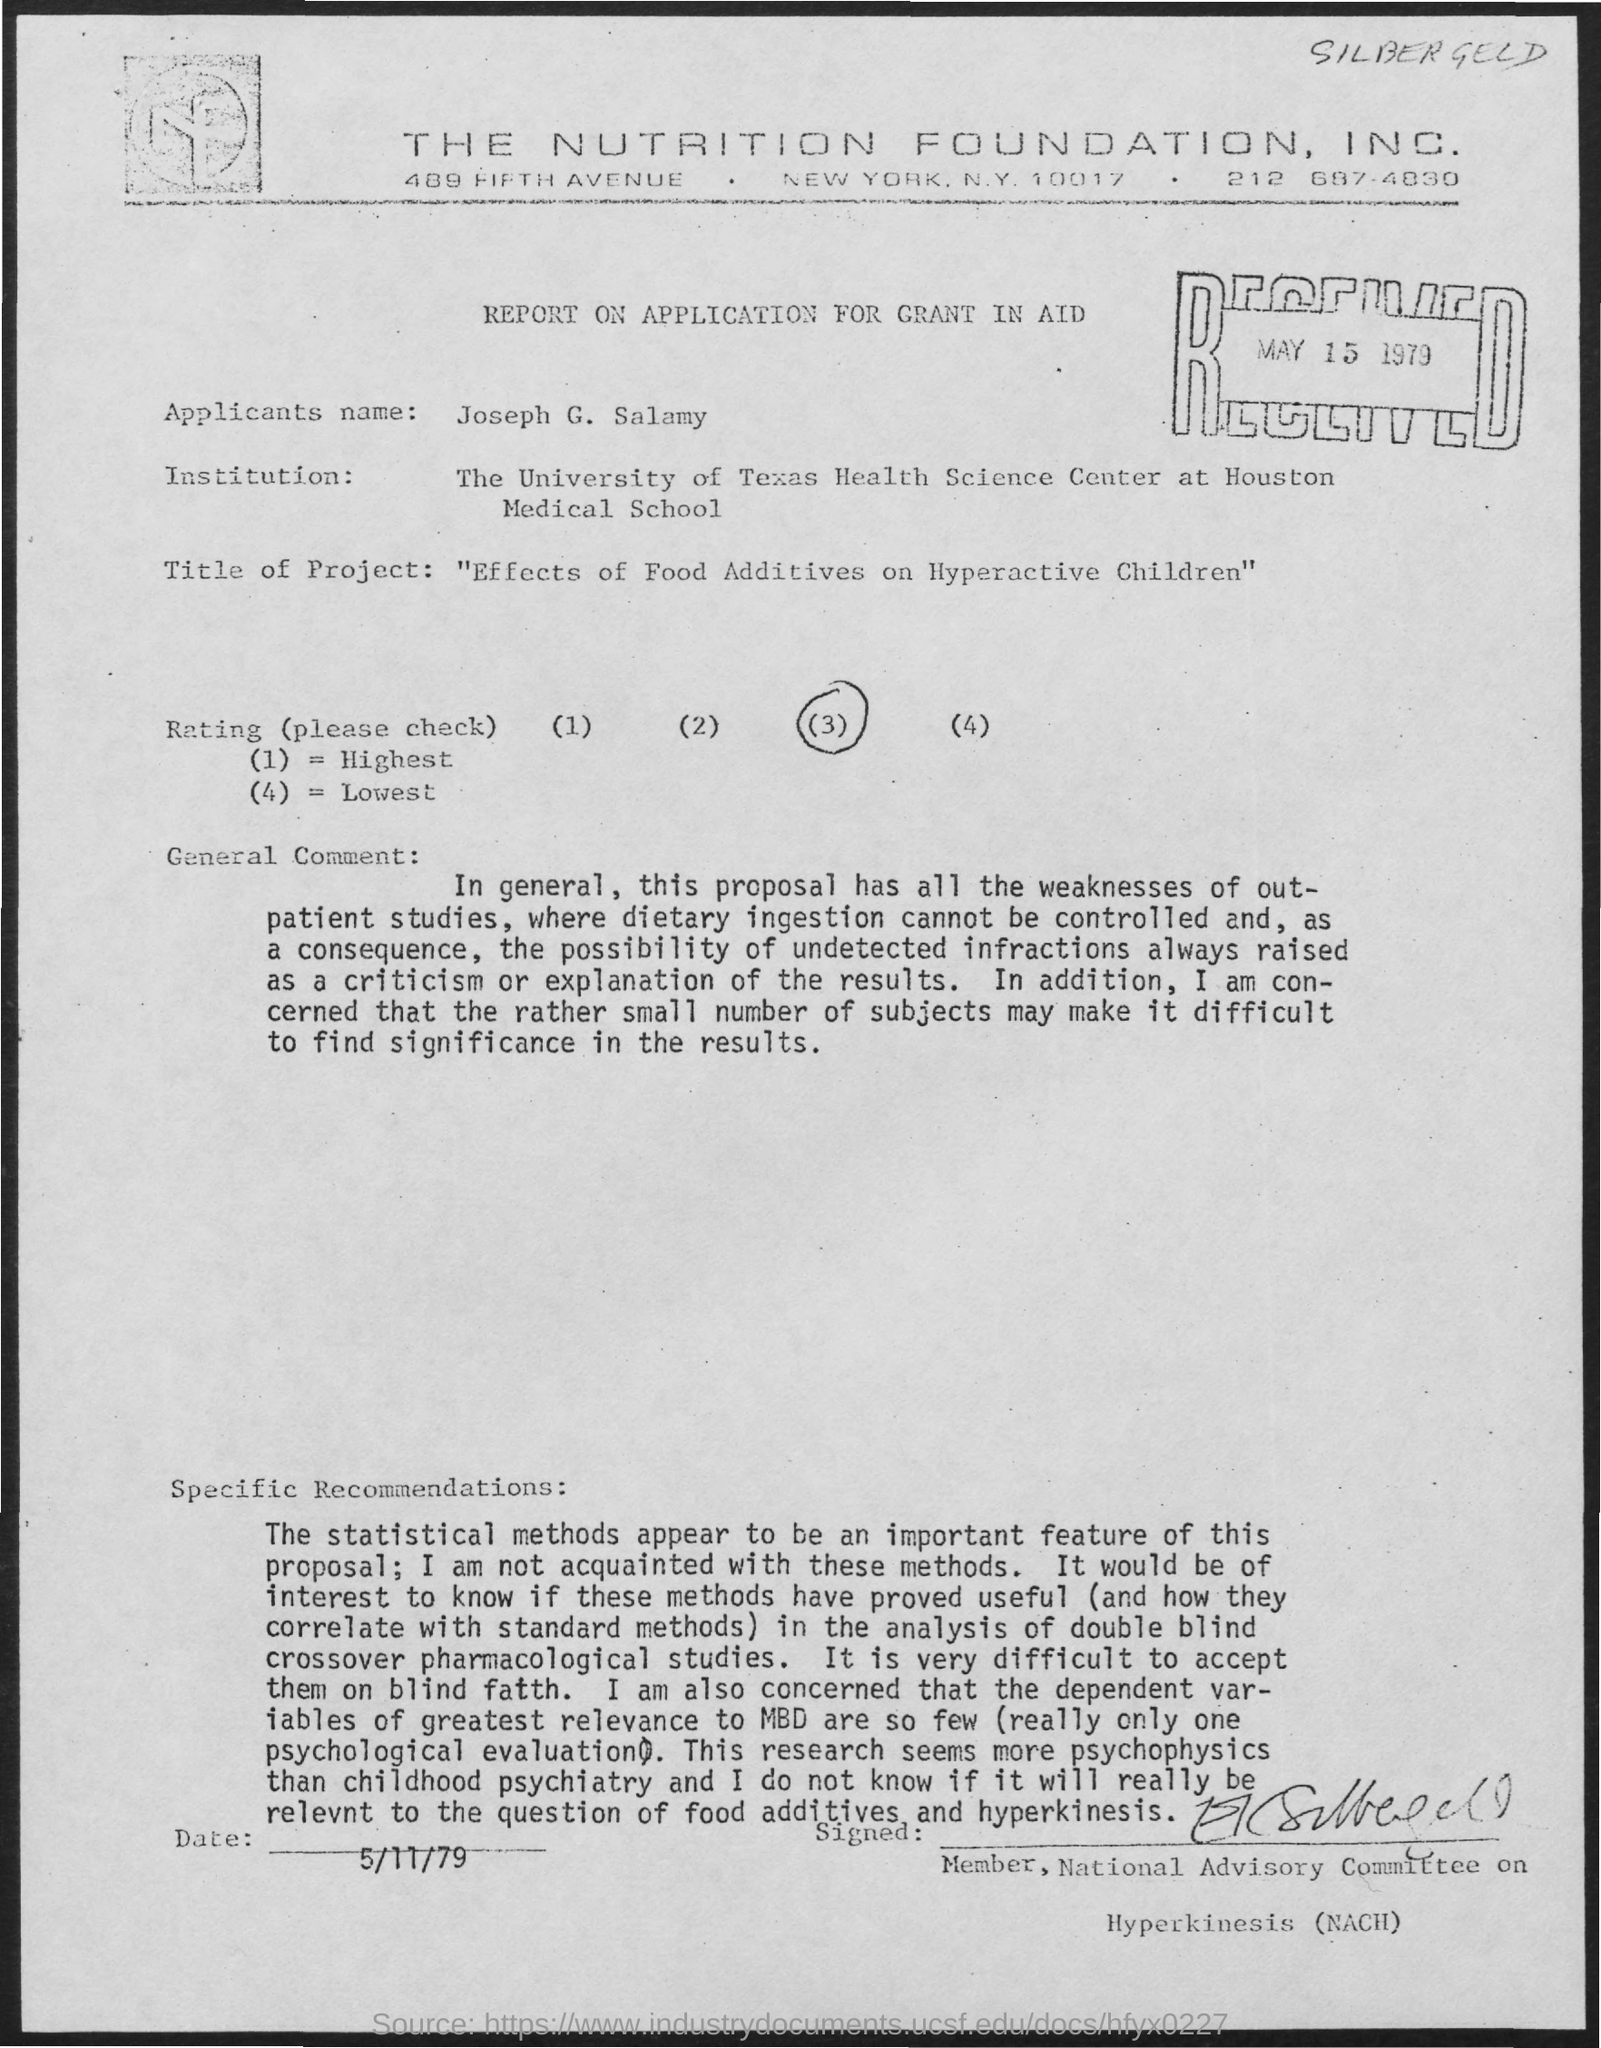What is the name of the FOUNDATION this document belongs to?
Make the answer very short. THE NUTRITION FOUNDATION, INC. When was this document RECEIVED?
Keep it short and to the point. MAY 15 1979. What is the Rating chosen in this document?
Make the answer very short. (3). What is the Applicant's name?
Keep it short and to the point. Joseph G. Salamy. 